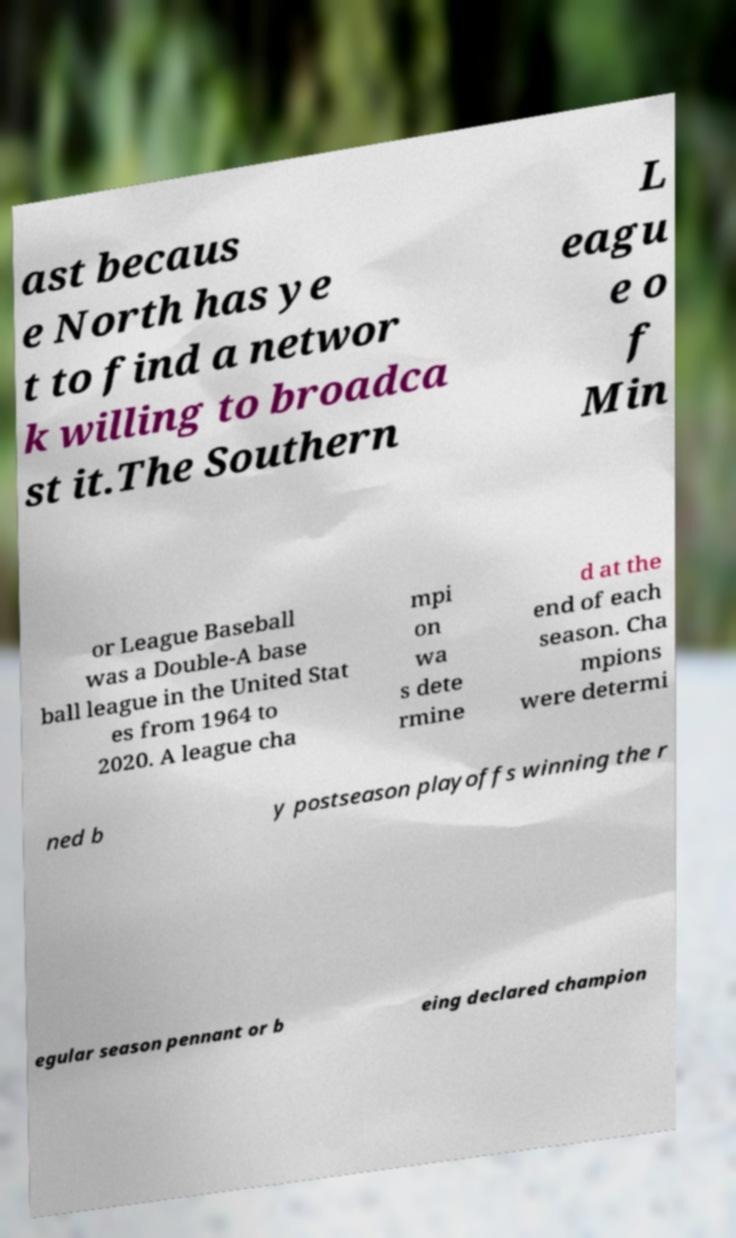Could you assist in decoding the text presented in this image and type it out clearly? ast becaus e North has ye t to find a networ k willing to broadca st it.The Southern L eagu e o f Min or League Baseball was a Double-A base ball league in the United Stat es from 1964 to 2020. A league cha mpi on wa s dete rmine d at the end of each season. Cha mpions were determi ned b y postseason playoffs winning the r egular season pennant or b eing declared champion 